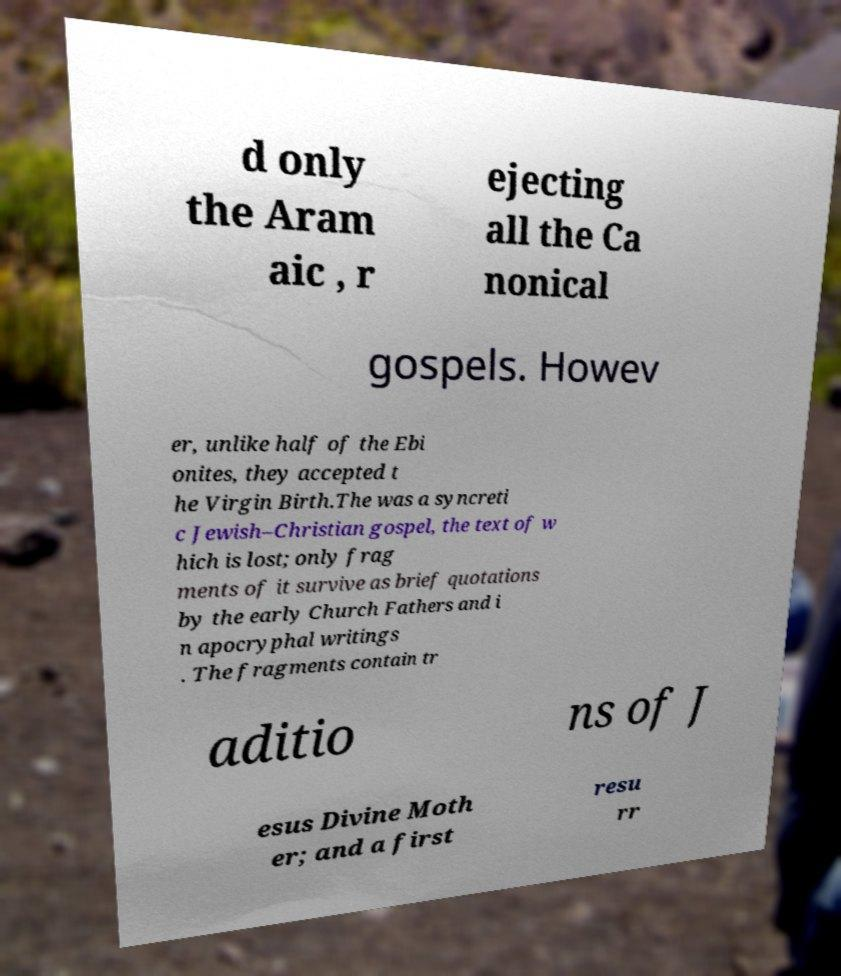Please read and relay the text visible in this image. What does it say? d only the Aram aic , r ejecting all the Ca nonical gospels. Howev er, unlike half of the Ebi onites, they accepted t he Virgin Birth.The was a syncreti c Jewish–Christian gospel, the text of w hich is lost; only frag ments of it survive as brief quotations by the early Church Fathers and i n apocryphal writings . The fragments contain tr aditio ns of J esus Divine Moth er; and a first resu rr 